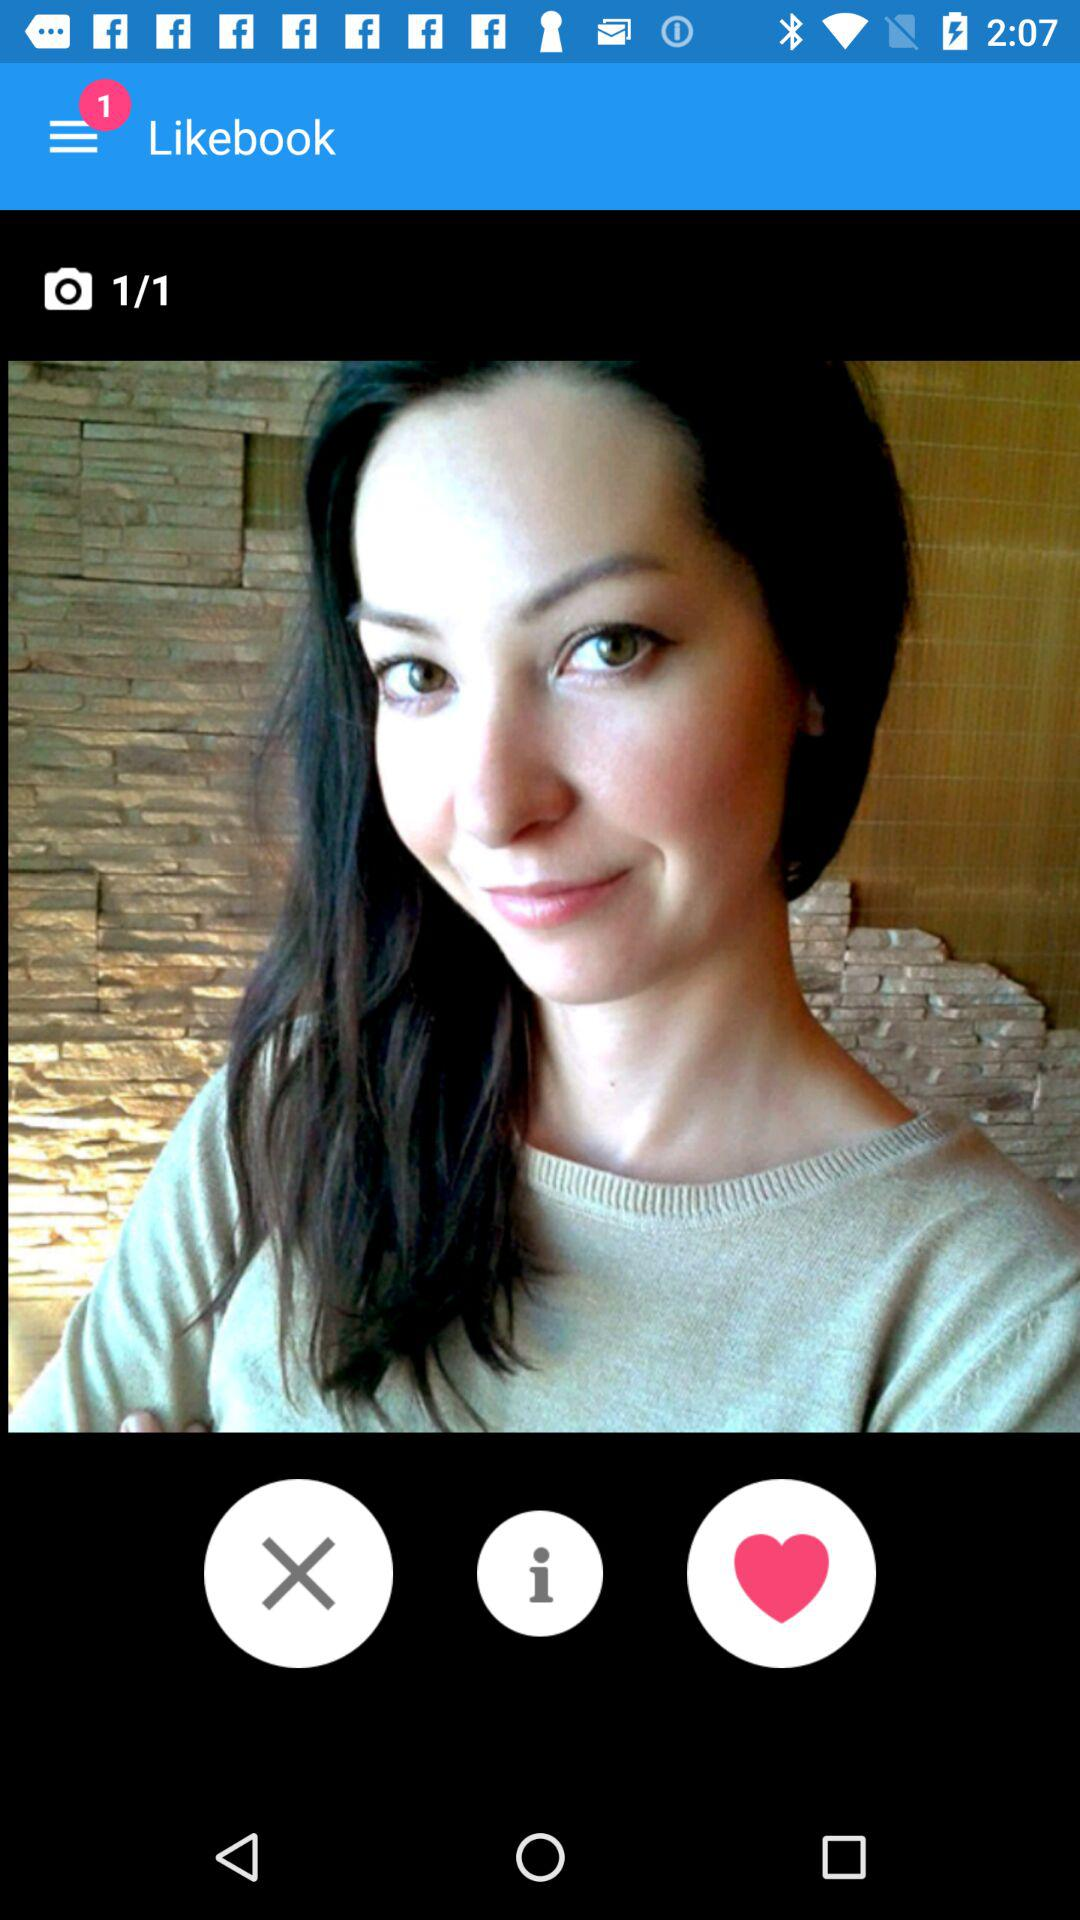How many images in total are there? There is a total of 1 image. 